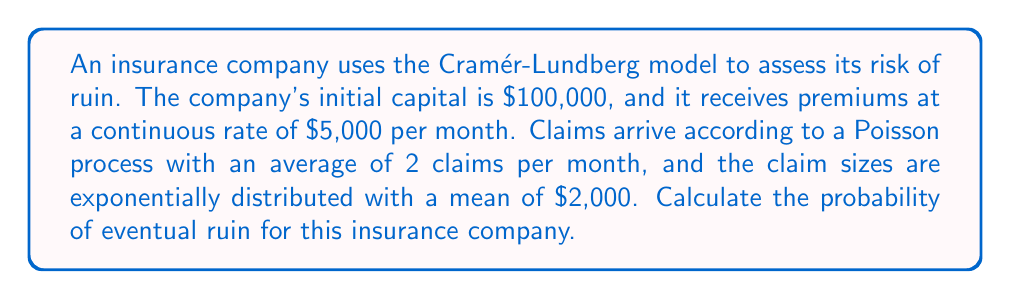Solve this math problem. Let's approach this step-by-step using the Cramér-Lundberg model:

1) First, we need to calculate the net profit condition:
   $$c > \lambda \mu$$
   where $c$ is the premium rate, $\lambda$ is the claim arrival rate, and $\mu$ is the mean claim size.

2) In this case:
   $c = 5,000$ per month
   $\lambda = 2$ claims per month
   $\mu = 2,000$ per claim

3) Checking the net profit condition:
   $$5,000 > 2 \times 2,000 = 4,000$$
   This condition is satisfied, so we can proceed.

4) Next, we need to find the adjustment coefficient $R$, which satisfies:
   $$c = \lambda \mu \left(\frac{MX(R)}{R}\right)$$
   where $MX(R)$ is the moment generating function of the claim size distribution.

5) For exponentially distributed claims with mean $\mu$, $MX(R) = \frac{1}{1-\mu R}$

6) Substituting into the equation:
   $$5,000 = 2 \times 2,000 \left(\frac{1}{R(1-2,000R)}\right)$$

7) Solving this equation (which can be done numerically), we get:
   $$R \approx 0.0002731$$

8) Finally, the probability of ruin with initial capital $u$ is given by:
   $$\psi(u) = \frac{1}{\mu R} e^{-Ru}$$

9) With $u = 100,000$, we can calculate:
   $$\psi(100,000) = \frac{1}{2,000 \times 0.0002731} e^{-0.0002731 \times 100,000} \approx 0.0022$$

Therefore, the probability of eventual ruin is approximately 0.0022 or 0.22%.
Answer: 0.0022 